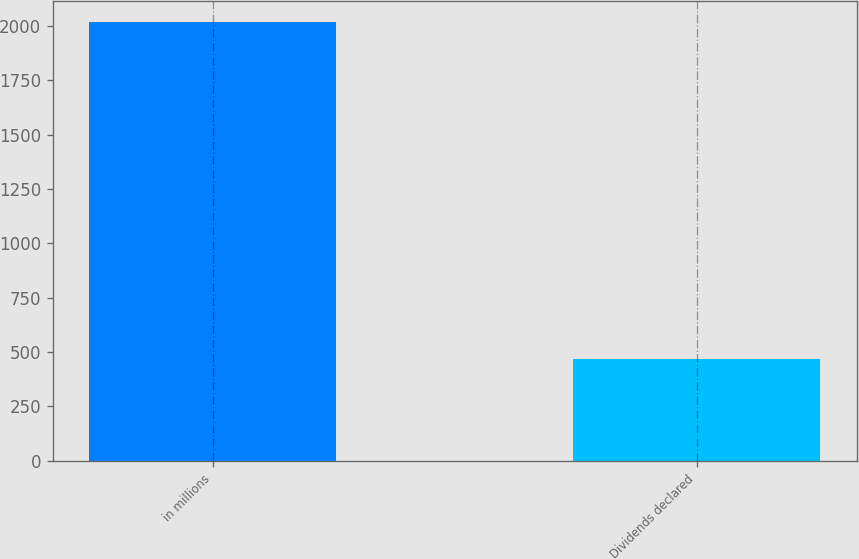<chart> <loc_0><loc_0><loc_500><loc_500><bar_chart><fcel>in millions<fcel>Dividends declared<nl><fcel>2016<fcel>468<nl></chart> 